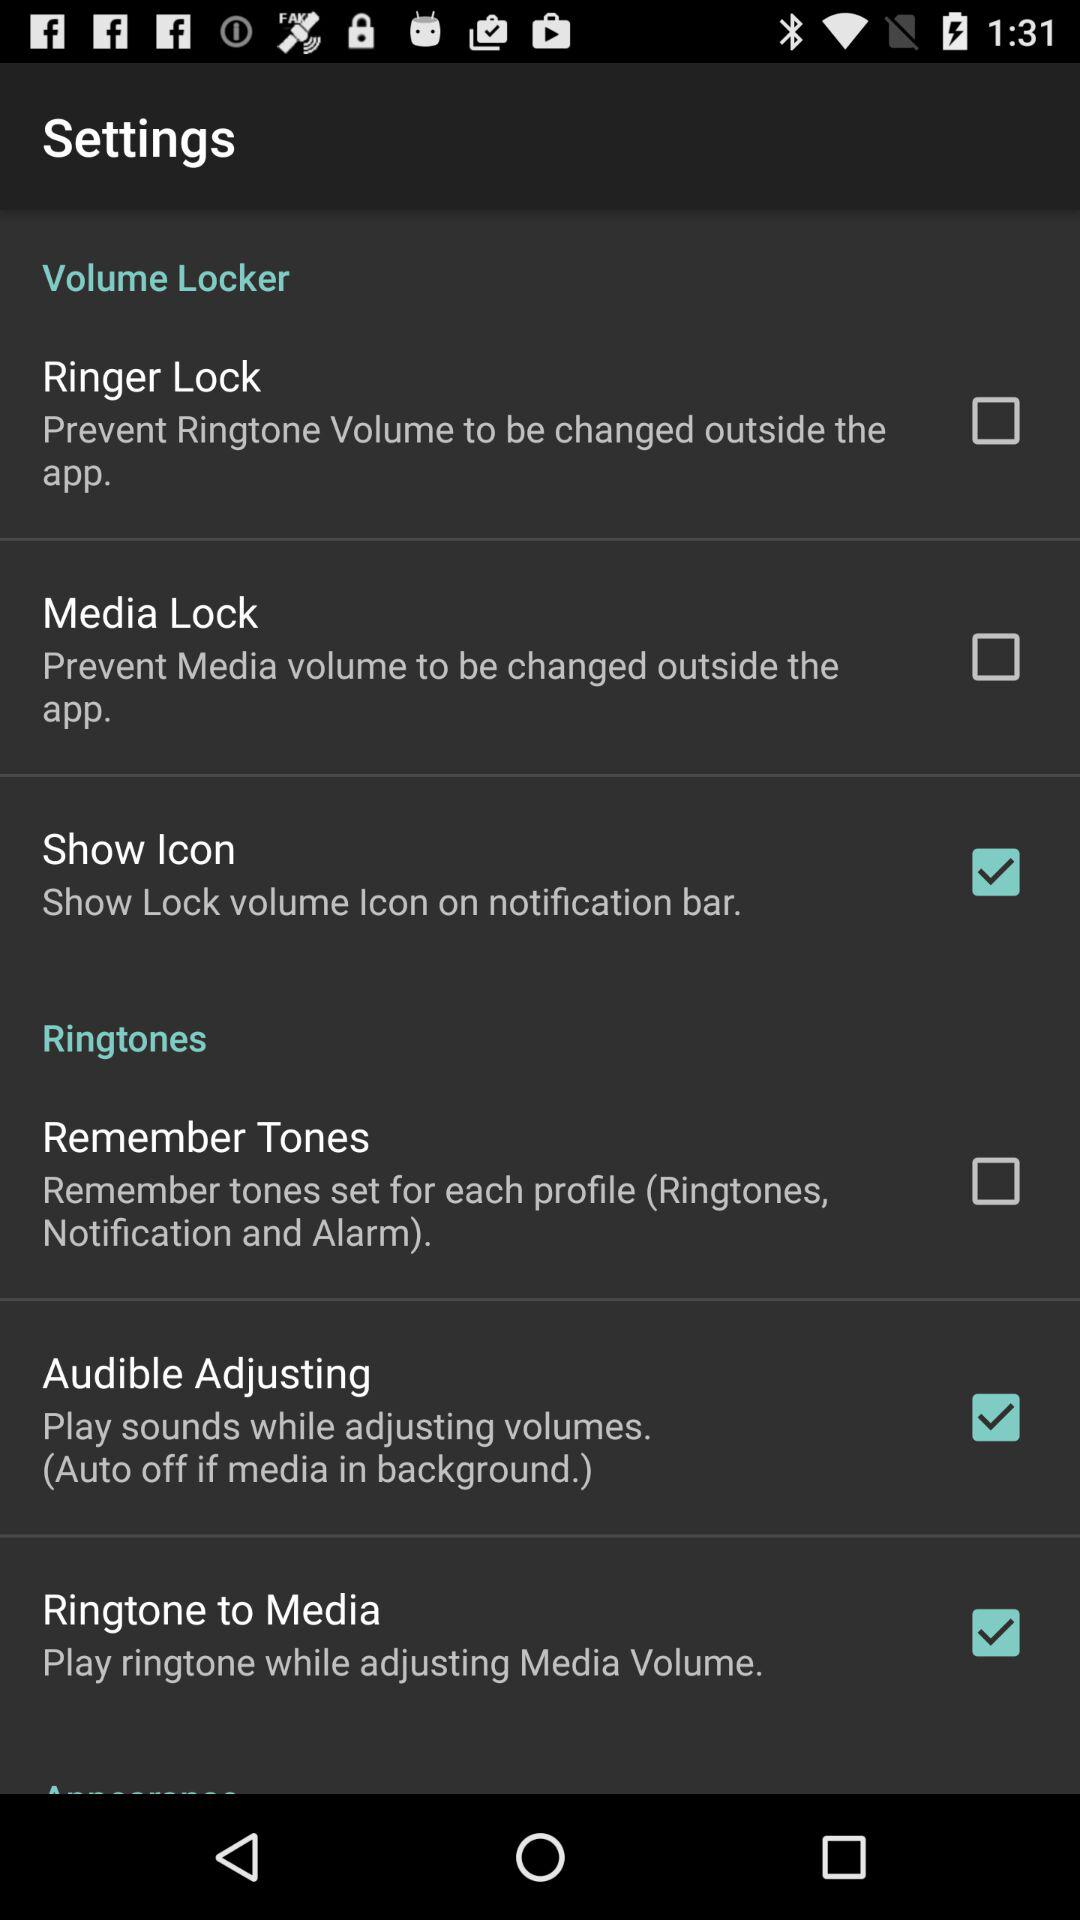What is the status of "Media Lock"? The status is "off". 